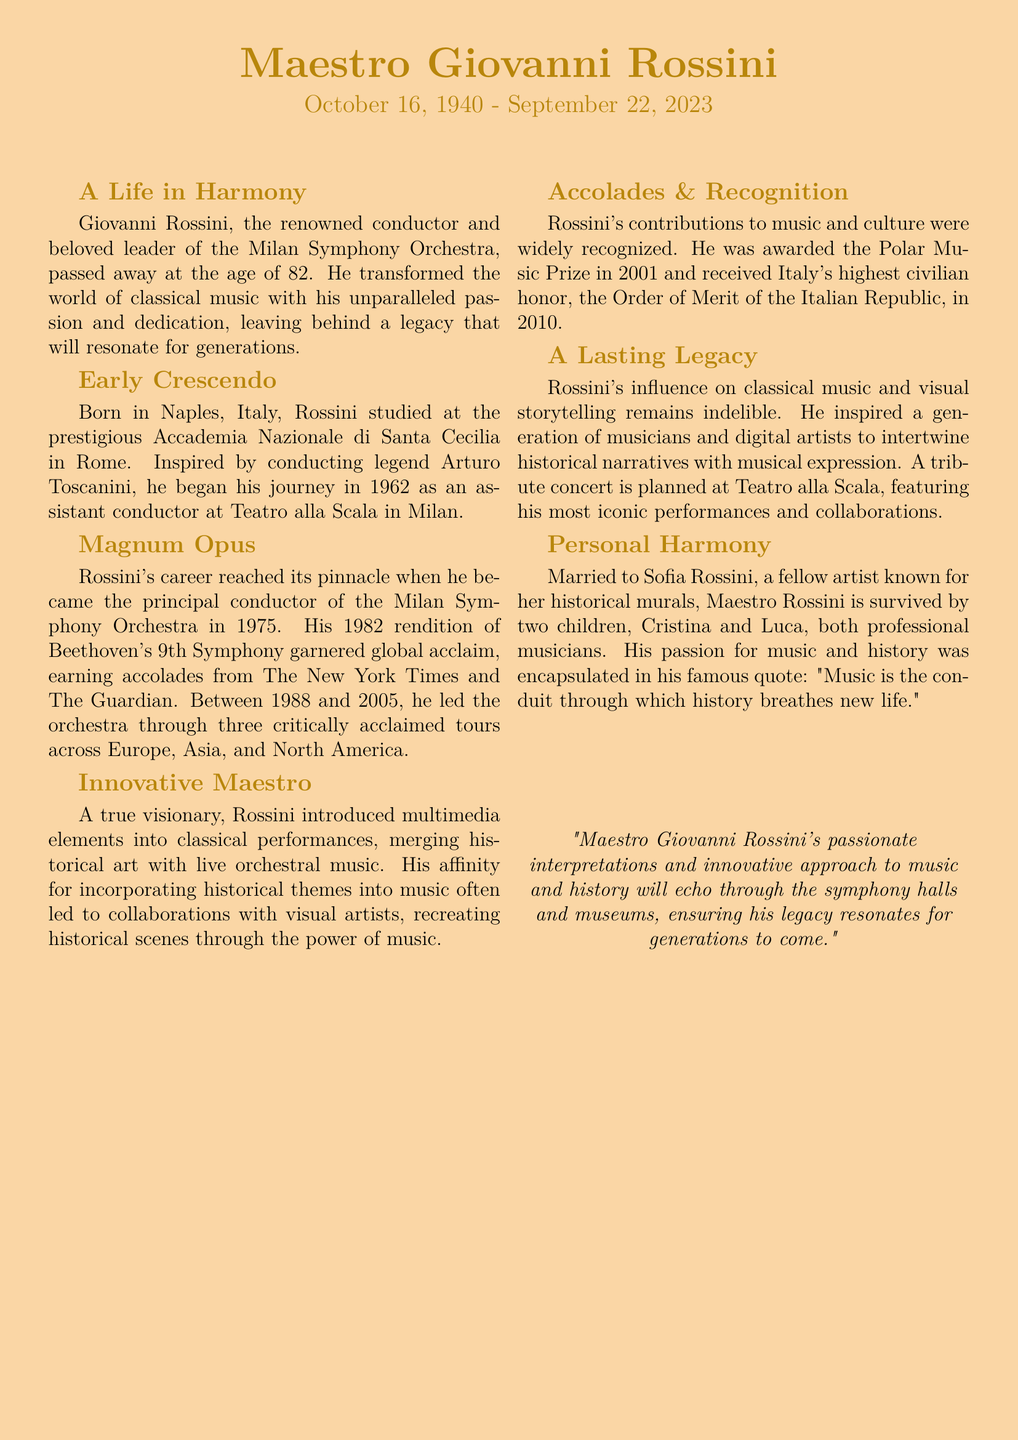What was the date of Giovanni Rossini's passing? The document states that Giovanni Rossini passed away on September 22, 2023.
Answer: September 22, 2023 What award did Rossini receive in 2001? The document mentions that Rossini was awarded the Polar Music Prize in 2001.
Answer: Polar Music Prize In which city was Giovanni Rossini born? The document indicates that Rossini was born in Naples, Italy.
Answer: Naples What was the title of Rossini's acclaimed 1982 performance? The document refers to his 1982 rendition of Beethoven's 9th Symphony as globally acclaimed.
Answer: Beethoven's 9th Symphony How many children did Maestro Rossini have? The document states that he is survived by two children.
Answer: Two What significant cultural honor did Rossini receive in 2010? The document notes that Rossini received the Order of Merit of the Italian Republic in 2010.
Answer: Order of Merit of the Italian Republic What role did Giovanni Rossini hold in the Milan Symphony Orchestra in 1975? The document indicates that he became the principal conductor of the Milan Symphony Orchestra in 1975.
Answer: Principal conductor What was Rossini's famous quote about music? The document cites his quote: "Music is the conduit through which history breathes new life."
Answer: "Music is the conduit through which history breathes new life." What type of concert is planned in tribute to Rossini? The document mentions a tribute concert at Teatro alla Scala featuring his most iconic performances.
Answer: Tribute concert 